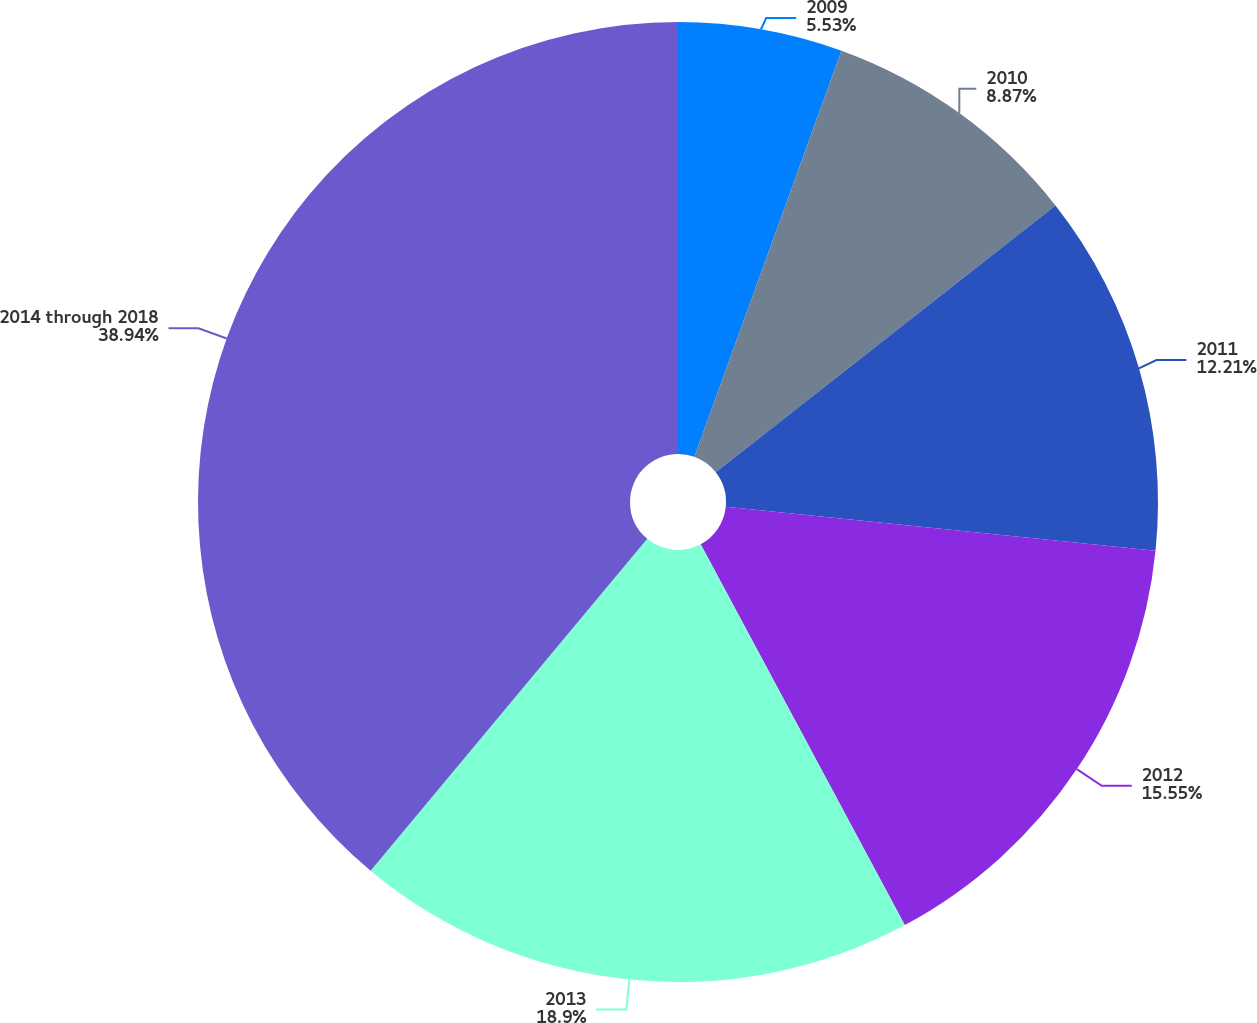Convert chart. <chart><loc_0><loc_0><loc_500><loc_500><pie_chart><fcel>2009<fcel>2010<fcel>2011<fcel>2012<fcel>2013<fcel>2014 through 2018<nl><fcel>5.53%<fcel>8.87%<fcel>12.21%<fcel>15.55%<fcel>18.89%<fcel>38.93%<nl></chart> 